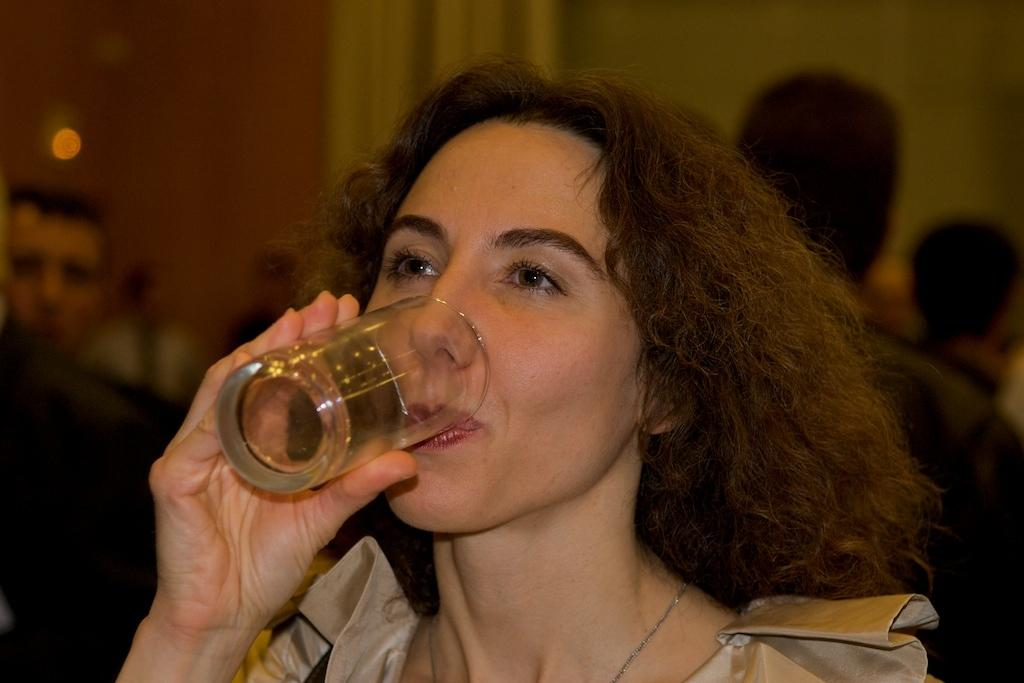Who is the main subject in the image? There is a woman in the image. What is the woman doing in the image? The woman is drinking water from a glass. Can you describe the background of the image? There are people visible in the background of the image. What can be seen in the image that provides light? There is a light in the image. How many volleyballs are being used by the woman in the image? There are no volleyballs present in the image. What type of wealth is the woman displaying in the image? There is no indication of wealth in the image; it simply shows a woman drinking water from a glass. 